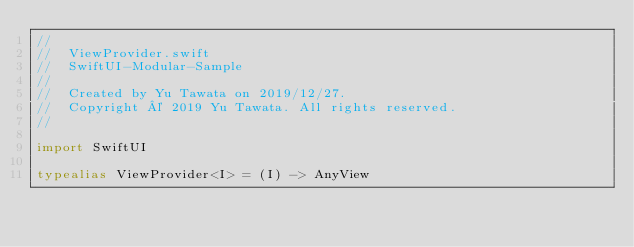Convert code to text. <code><loc_0><loc_0><loc_500><loc_500><_Swift_>//
//  ViewProvider.swift
//  SwiftUI-Modular-Sample
//
//  Created by Yu Tawata on 2019/12/27.
//  Copyright © 2019 Yu Tawata. All rights reserved.
//

import SwiftUI

typealias ViewProvider<I> = (I) -> AnyView
</code> 